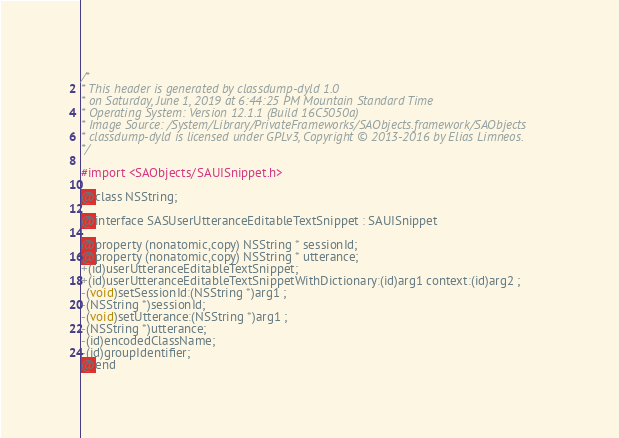<code> <loc_0><loc_0><loc_500><loc_500><_C_>/*
* This header is generated by classdump-dyld 1.0
* on Saturday, June 1, 2019 at 6:44:25 PM Mountain Standard Time
* Operating System: Version 12.1.1 (Build 16C5050a)
* Image Source: /System/Library/PrivateFrameworks/SAObjects.framework/SAObjects
* classdump-dyld is licensed under GPLv3, Copyright © 2013-2016 by Elias Limneos.
*/

#import <SAObjects/SAUISnippet.h>

@class NSString;

@interface SASUserUtteranceEditableTextSnippet : SAUISnippet

@property (nonatomic,copy) NSString * sessionId; 
@property (nonatomic,copy) NSString * utterance; 
+(id)userUtteranceEditableTextSnippet;
+(id)userUtteranceEditableTextSnippetWithDictionary:(id)arg1 context:(id)arg2 ;
-(void)setSessionId:(NSString *)arg1 ;
-(NSString *)sessionId;
-(void)setUtterance:(NSString *)arg1 ;
-(NSString *)utterance;
-(id)encodedClassName;
-(id)groupIdentifier;
@end

</code> 